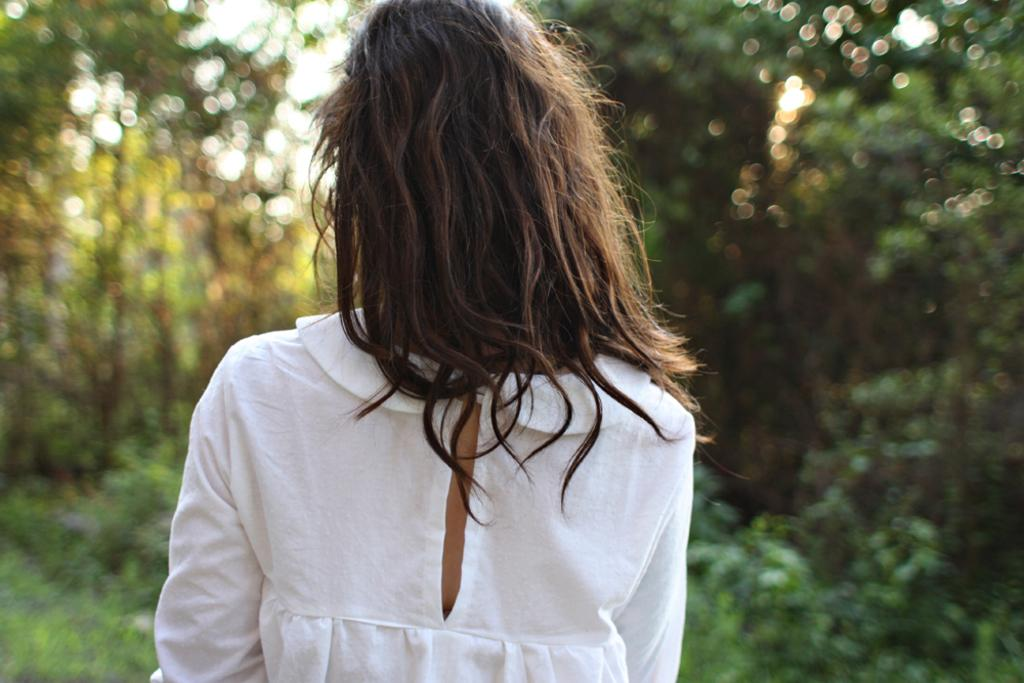What is the main subject of the image? The main subject of the image is a woman. What is the woman wearing in the image? The woman is wearing a white dress. What type of vegetation can be seen in the background of the image? There are green trees visible at the back side of the image. What type of food is the woman eating in the image? There is no indication in the image that the woman is eating any food, so it cannot be determined from the picture. Can you tell me how many steps are visible in the image? There is no reference to steps in the image, so it is not possible to determine how many steps might be visible. 